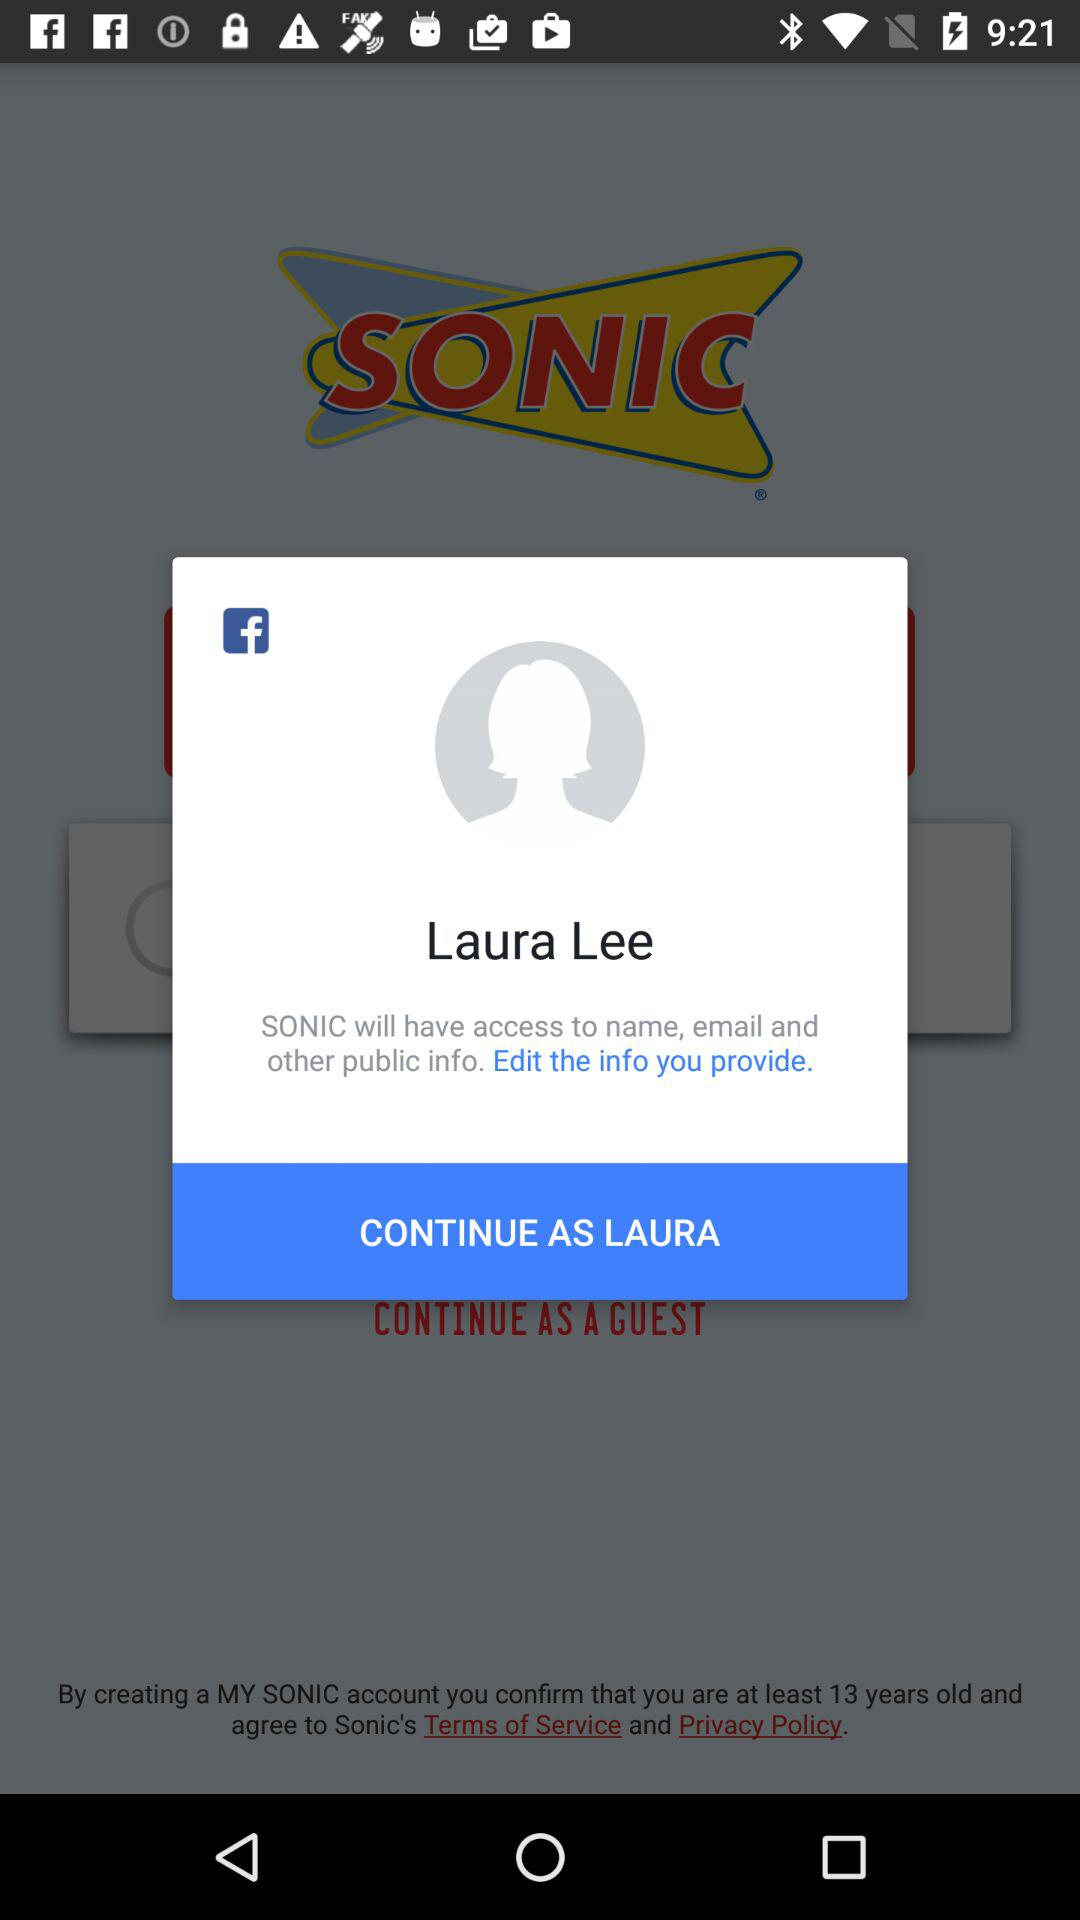How many more public info will SONIC have access to than name and email?
Answer the question using a single word or phrase. 1 